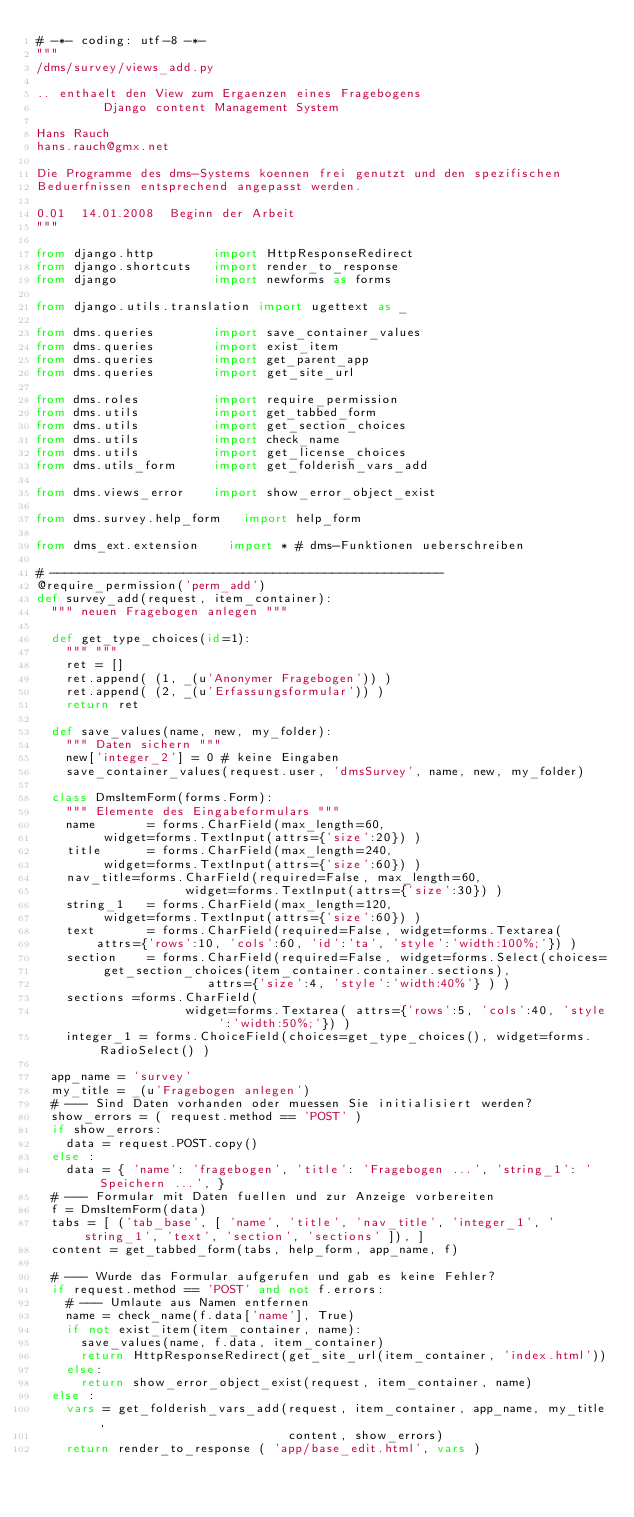<code> <loc_0><loc_0><loc_500><loc_500><_Python_># -*- coding: utf-8 -*-
"""
/dms/survey/views_add.py

.. enthaelt den View zum Ergaenzen eines Fragebogens
         Django content Management System

Hans Rauch
hans.rauch@gmx.net

Die Programme des dms-Systems koennen frei genutzt und den spezifischen
Beduerfnissen entsprechend angepasst werden.

0.01  14.01.2008  Beginn der Arbeit
"""

from django.http        import HttpResponseRedirect
from django.shortcuts   import render_to_response
from django             import newforms as forms

from django.utils.translation import ugettext as _

from dms.queries        import save_container_values
from dms.queries        import exist_item
from dms.queries        import get_parent_app
from dms.queries        import get_site_url

from dms.roles          import require_permission
from dms.utils          import get_tabbed_form
from dms.utils          import get_section_choices
from dms.utils          import check_name
from dms.utils          import get_license_choices
from dms.utils_form     import get_folderish_vars_add

from dms.views_error    import show_error_object_exist

from dms.survey.help_form   import help_form

from dms_ext.extension    import * # dms-Funktionen ueberschreiben

# -----------------------------------------------------
@require_permission('perm_add')
def survey_add(request, item_container):
  """ neuen Fragebogen anlegen """

  def get_type_choices(id=1):
    """ """
    ret = []
    ret.append( (1, _(u'Anonymer Fragebogen')) )
    ret.append( (2, _(u'Erfassungsformular')) )
    return ret

  def save_values(name, new, my_folder):
    """ Daten sichern """
    new['integer_2'] = 0 # keine Eingaben
    save_container_values(request.user, 'dmsSurvey', name, new, my_folder)

  class DmsItemForm(forms.Form):
    """ Elemente des Eingabeformulars """
    name       = forms.CharField(max_length=60,
         widget=forms.TextInput(attrs={'size':20}) )
    title      = forms.CharField(max_length=240,
         widget=forms.TextInput(attrs={'size':60}) )
    nav_title=forms.CharField(required=False, max_length=60,
                    widget=forms.TextInput(attrs={'size':30}) )
    string_1   = forms.CharField(max_length=120,
         widget=forms.TextInput(attrs={'size':60}) )
    text       = forms.CharField(required=False, widget=forms.Textarea(
        attrs={'rows':10, 'cols':60, 'id':'ta', 'style':'width:100%;'}) )
    section    = forms.CharField(required=False, widget=forms.Select(choices=
         get_section_choices(item_container.container.sections),
                       attrs={'size':4, 'style':'width:40%'} ) )
    sections =forms.CharField(
                    widget=forms.Textarea( attrs={'rows':5, 'cols':40, 'style':'width:50%;'}) )
    integer_1 = forms.ChoiceField(choices=get_type_choices(), widget=forms.RadioSelect() )

  app_name = 'survey'
  my_title = _(u'Fragebogen anlegen')
  # --- Sind Daten vorhanden oder muessen Sie initialisiert werden?
  show_errors = ( request.method == 'POST' )
  if show_errors:
    data = request.POST.copy()
  else :
    data = { 'name': 'fragebogen', 'title': 'Fragebogen ...', 'string_1': 'Speichern ...', }
  # --- Formular mit Daten fuellen und zur Anzeige vorbereiten
  f = DmsItemForm(data)
  tabs = [ ('tab_base', [ 'name', 'title', 'nav_title', 'integer_1', 'string_1', 'text', 'section', 'sections' ]), ]
  content = get_tabbed_form(tabs, help_form, app_name, f)

  # --- Wurde das Formular aufgerufen und gab es keine Fehler?
  if request.method == 'POST' and not f.errors:
    # --- Umlaute aus Namen entfernen
    name = check_name(f.data['name'], True)
    if not exist_item(item_container, name):
      save_values(name, f.data, item_container)
      return HttpResponseRedirect(get_site_url(item_container, 'index.html'))
    else:
      return show_error_object_exist(request, item_container, name)
  else :
    vars = get_folderish_vars_add(request, item_container, app_name, my_title,
                                  content, show_errors)
    return render_to_response ( 'app/base_edit.html', vars )
</code> 